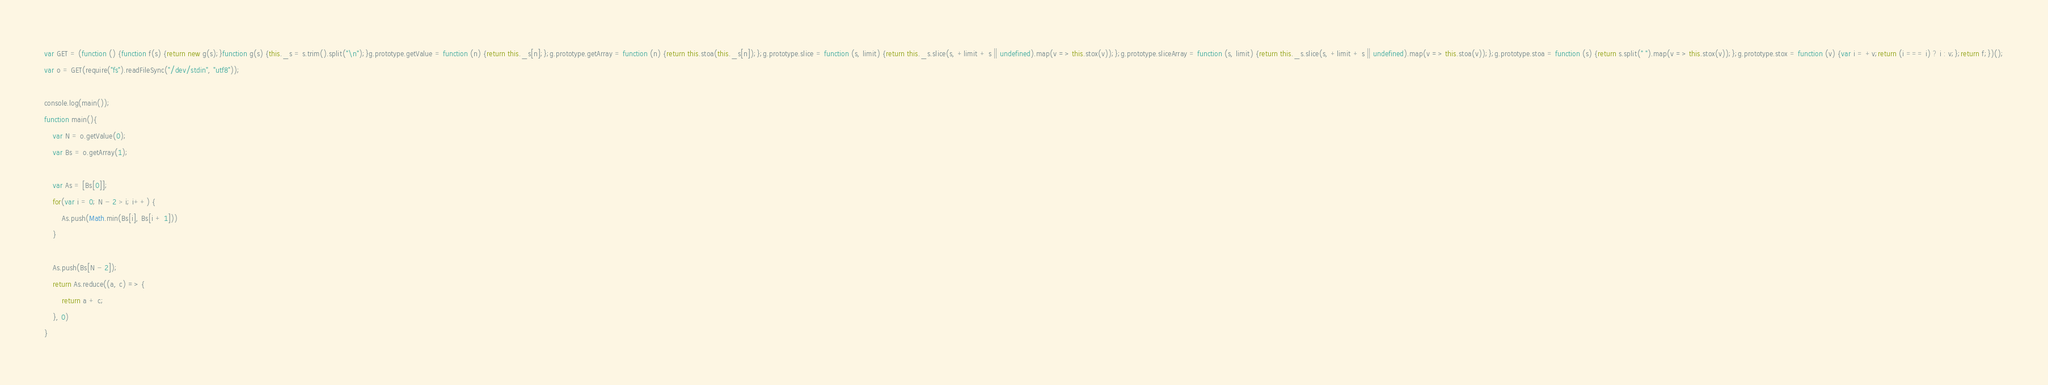<code> <loc_0><loc_0><loc_500><loc_500><_JavaScript_>var GET = (function () {function f(s) {return new g(s);}function g(s) {this._s = s.trim().split("\n");}g.prototype.getValue = function (n) {return this._s[n];};g.prototype.getArray = function (n) {return this.stoa(this._s[n]);};g.prototype.slice = function (s, limit) {return this._s.slice(s, +limit + s || undefined).map(v => this.stox(v));};g.prototype.sliceArray = function (s, limit) {return this._s.slice(s, +limit + s || undefined).map(v => this.stoa(v));};g.prototype.stoa = function (s) {return s.split(" ").map(v => this.stox(v));};g.prototype.stox = function (v) {var i = +v;return (i === i) ? i : v;};return f;})();
var o = GET(require("fs").readFileSync("/dev/stdin", "utf8"));

console.log(main());
function main(){
    var N = o.getValue(0);
    var Bs = o.getArray(1);

    var As = [Bs[0]];
    for(var i = 0; N - 2 > i; i++) {
        As.push(Math.min(Bs[i], Bs[i + 1]))
    }

    As.push(Bs[N - 2]);
    return As.reduce((a, c) => {
        return a + c;
    }, 0)
}
</code> 